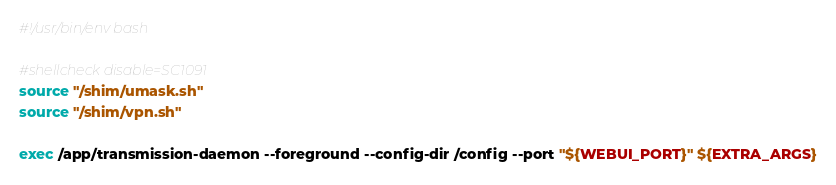Convert code to text. <code><loc_0><loc_0><loc_500><loc_500><_Bash_>#!/usr/bin/env bash

#shellcheck disable=SC1091
source "/shim/umask.sh"
source "/shim/vpn.sh"

exec /app/transmission-daemon --foreground --config-dir /config --port "${WEBUI_PORT}" ${EXTRA_ARGS}
</code> 